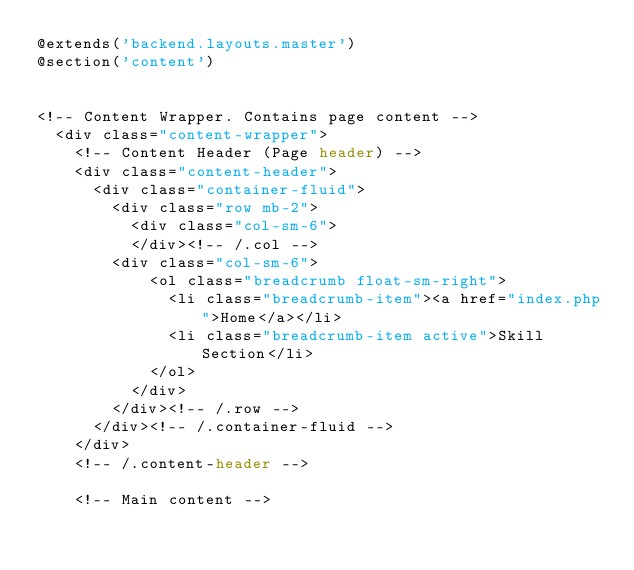<code> <loc_0><loc_0><loc_500><loc_500><_PHP_>@extends('backend.layouts.master')
@section('content')


<!-- Content Wrapper. Contains page content -->
  <div class="content-wrapper">
    <!-- Content Header (Page header) -->
    <div class="content-header">
      <div class="container-fluid">
        <div class="row mb-2">
          <div class="col-sm-6">
          </div><!-- /.col -->
        <div class="col-sm-6">
            <ol class="breadcrumb float-sm-right">
              <li class="breadcrumb-item"><a href="index.php">Home</a></li>
              <li class="breadcrumb-item active">Skill Section</li>
            </ol>
          </div>
        </div><!-- /.row -->
      </div><!-- /.container-fluid -->
    </div>
    <!-- /.content-header -->

    <!-- Main content --></code> 